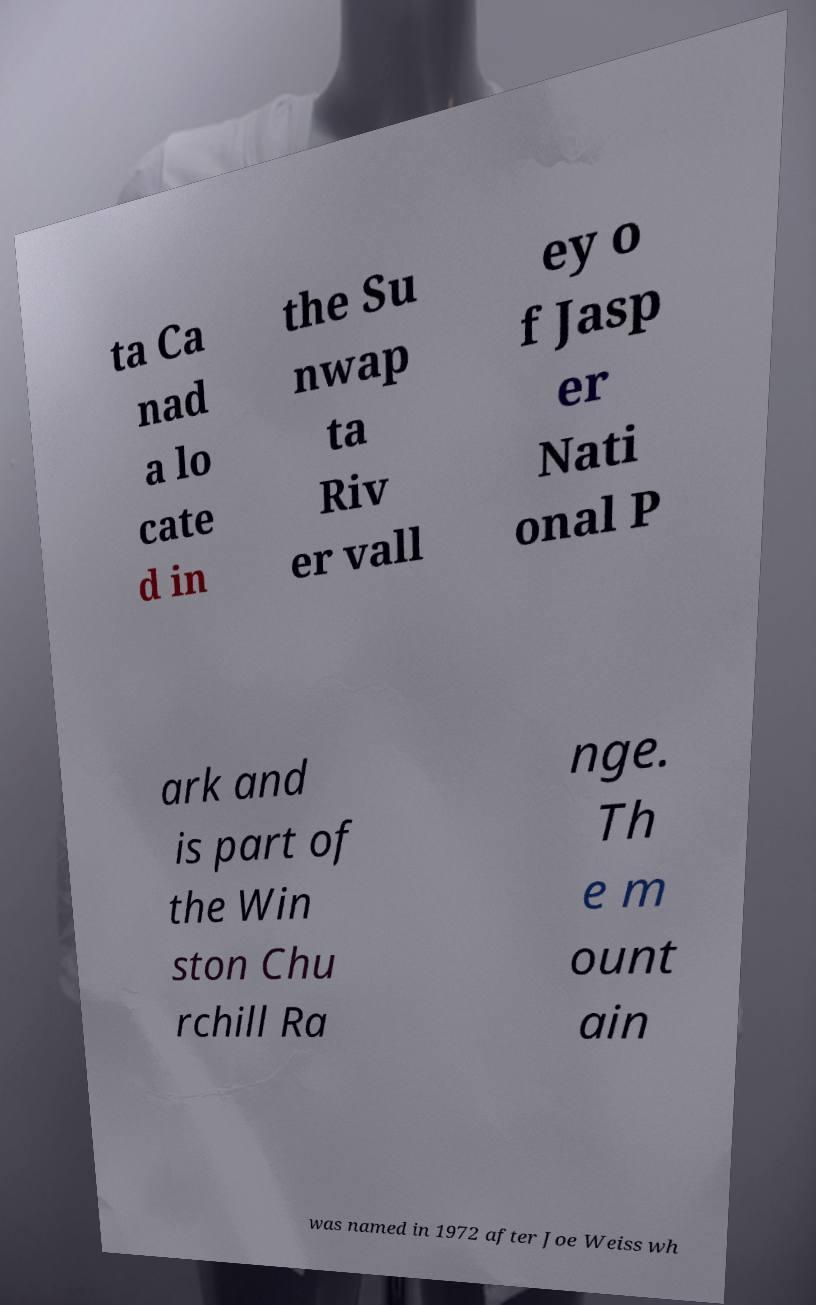Can you accurately transcribe the text from the provided image for me? ta Ca nad a lo cate d in the Su nwap ta Riv er vall ey o f Jasp er Nati onal P ark and is part of the Win ston Chu rchill Ra nge. Th e m ount ain was named in 1972 after Joe Weiss wh 